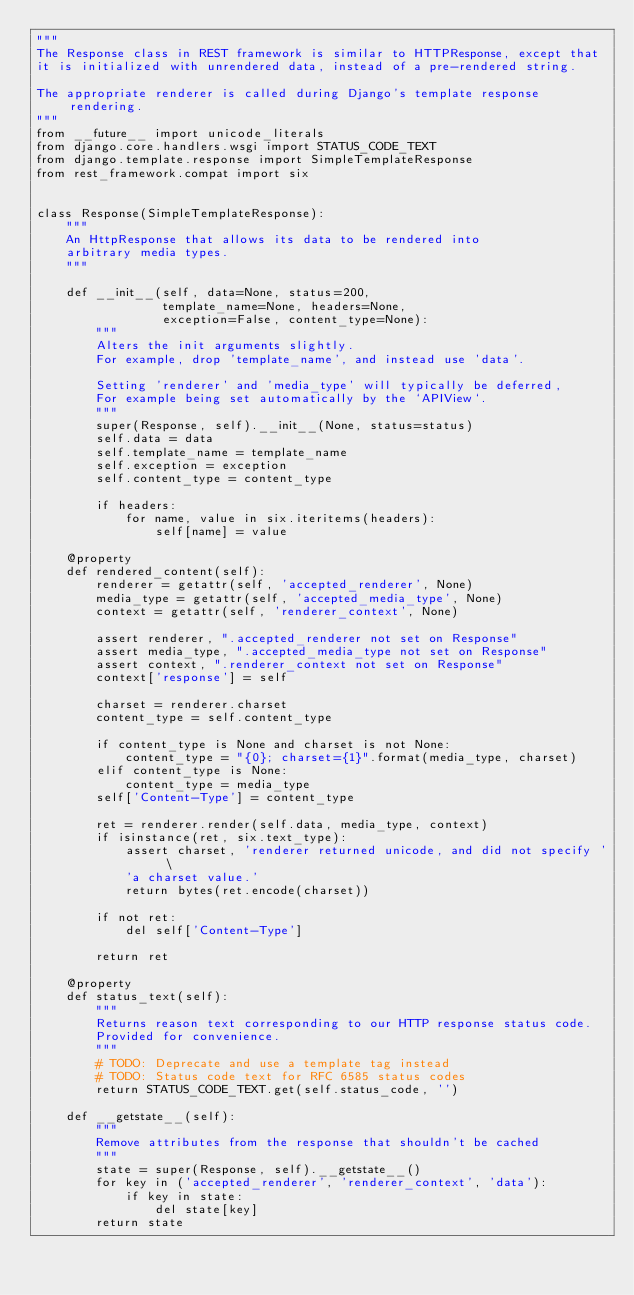<code> <loc_0><loc_0><loc_500><loc_500><_Python_>"""
The Response class in REST framework is similar to HTTPResponse, except that
it is initialized with unrendered data, instead of a pre-rendered string.

The appropriate renderer is called during Django's template response rendering.
"""
from __future__ import unicode_literals
from django.core.handlers.wsgi import STATUS_CODE_TEXT
from django.template.response import SimpleTemplateResponse
from rest_framework.compat import six


class Response(SimpleTemplateResponse):
    """
    An HttpResponse that allows its data to be rendered into
    arbitrary media types.
    """

    def __init__(self, data=None, status=200,
                 template_name=None, headers=None,
                 exception=False, content_type=None):
        """
        Alters the init arguments slightly.
        For example, drop 'template_name', and instead use 'data'.

        Setting 'renderer' and 'media_type' will typically be deferred,
        For example being set automatically by the `APIView`.
        """
        super(Response, self).__init__(None, status=status)
        self.data = data
        self.template_name = template_name
        self.exception = exception
        self.content_type = content_type

        if headers:
            for name, value in six.iteritems(headers):
                self[name] = value

    @property
    def rendered_content(self):
        renderer = getattr(self, 'accepted_renderer', None)
        media_type = getattr(self, 'accepted_media_type', None)
        context = getattr(self, 'renderer_context', None)

        assert renderer, ".accepted_renderer not set on Response"
        assert media_type, ".accepted_media_type not set on Response"
        assert context, ".renderer_context not set on Response"
        context['response'] = self

        charset = renderer.charset
        content_type = self.content_type

        if content_type is None and charset is not None:
            content_type = "{0}; charset={1}".format(media_type, charset)
        elif content_type is None:
            content_type = media_type
        self['Content-Type'] = content_type

        ret = renderer.render(self.data, media_type, context)
        if isinstance(ret, six.text_type):
            assert charset, 'renderer returned unicode, and did not specify ' \
            'a charset value.'
            return bytes(ret.encode(charset))

        if not ret:
            del self['Content-Type']

        return ret

    @property
    def status_text(self):
        """
        Returns reason text corresponding to our HTTP response status code.
        Provided for convenience.
        """
        # TODO: Deprecate and use a template tag instead
        # TODO: Status code text for RFC 6585 status codes
        return STATUS_CODE_TEXT.get(self.status_code, '')

    def __getstate__(self):
        """
        Remove attributes from the response that shouldn't be cached
        """
        state = super(Response, self).__getstate__()
        for key in ('accepted_renderer', 'renderer_context', 'data'):
            if key in state:
                del state[key]
        return state
</code> 